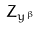<formula> <loc_0><loc_0><loc_500><loc_500>Z _ { y ^ { \beta } }</formula> 